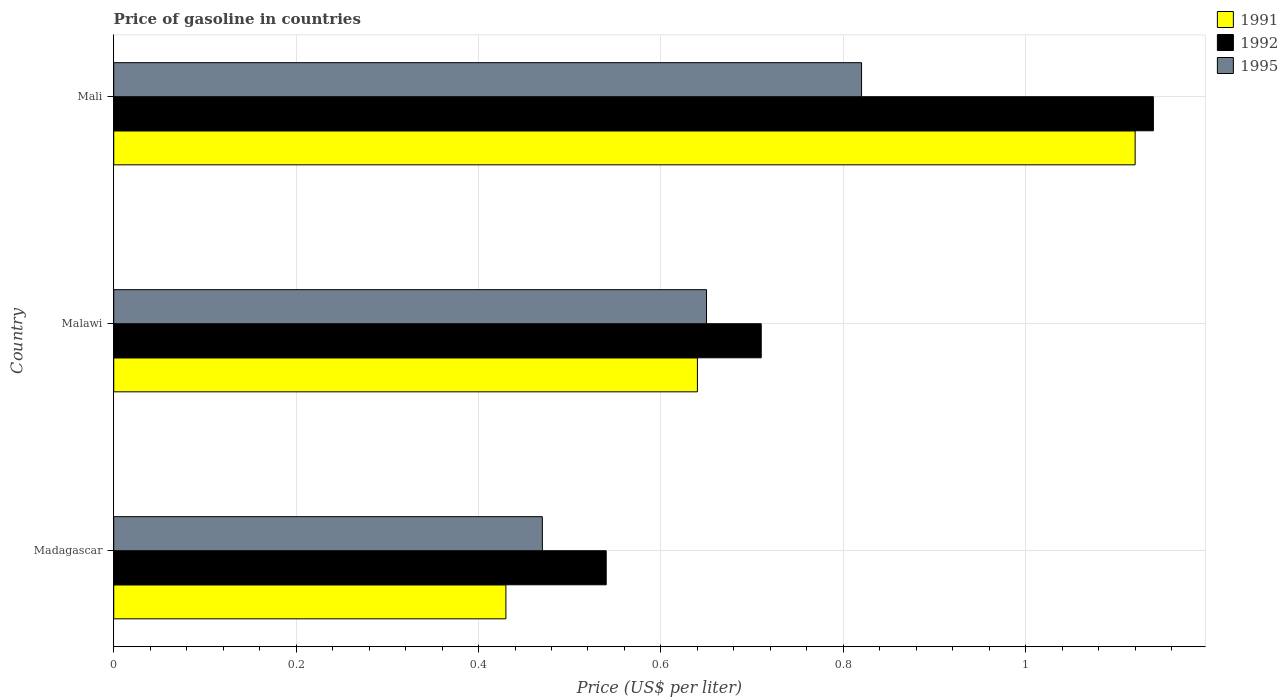How many groups of bars are there?
Make the answer very short. 3. Are the number of bars per tick equal to the number of legend labels?
Your response must be concise. Yes. Are the number of bars on each tick of the Y-axis equal?
Your answer should be compact. Yes. What is the label of the 1st group of bars from the top?
Ensure brevity in your answer.  Mali. In how many cases, is the number of bars for a given country not equal to the number of legend labels?
Make the answer very short. 0. What is the price of gasoline in 1995 in Mali?
Ensure brevity in your answer.  0.82. Across all countries, what is the maximum price of gasoline in 1992?
Your answer should be very brief. 1.14. Across all countries, what is the minimum price of gasoline in 1995?
Your answer should be very brief. 0.47. In which country was the price of gasoline in 1992 maximum?
Offer a very short reply. Mali. In which country was the price of gasoline in 1991 minimum?
Offer a terse response. Madagascar. What is the total price of gasoline in 1995 in the graph?
Provide a short and direct response. 1.94. What is the difference between the price of gasoline in 1992 in Madagascar and that in Mali?
Keep it short and to the point. -0.6. What is the difference between the price of gasoline in 1992 in Malawi and the price of gasoline in 1995 in Mali?
Offer a very short reply. -0.11. What is the average price of gasoline in 1992 per country?
Your answer should be very brief. 0.8. What is the difference between the price of gasoline in 1991 and price of gasoline in 1992 in Madagascar?
Offer a very short reply. -0.11. What is the ratio of the price of gasoline in 1991 in Madagascar to that in Mali?
Keep it short and to the point. 0.38. What is the difference between the highest and the second highest price of gasoline in 1991?
Your answer should be very brief. 0.48. What is the difference between the highest and the lowest price of gasoline in 1995?
Provide a short and direct response. 0.35. In how many countries, is the price of gasoline in 1995 greater than the average price of gasoline in 1995 taken over all countries?
Ensure brevity in your answer.  2. Is the sum of the price of gasoline in 1992 in Malawi and Mali greater than the maximum price of gasoline in 1995 across all countries?
Offer a very short reply. Yes. Is it the case that in every country, the sum of the price of gasoline in 1991 and price of gasoline in 1995 is greater than the price of gasoline in 1992?
Give a very brief answer. Yes. Are all the bars in the graph horizontal?
Your response must be concise. Yes. Are the values on the major ticks of X-axis written in scientific E-notation?
Offer a terse response. No. Does the graph contain any zero values?
Provide a short and direct response. No. How many legend labels are there?
Your response must be concise. 3. What is the title of the graph?
Provide a succinct answer. Price of gasoline in countries. What is the label or title of the X-axis?
Offer a terse response. Price (US$ per liter). What is the Price (US$ per liter) of 1991 in Madagascar?
Keep it short and to the point. 0.43. What is the Price (US$ per liter) in 1992 in Madagascar?
Offer a very short reply. 0.54. What is the Price (US$ per liter) in 1995 in Madagascar?
Your answer should be compact. 0.47. What is the Price (US$ per liter) in 1991 in Malawi?
Provide a succinct answer. 0.64. What is the Price (US$ per liter) of 1992 in Malawi?
Your answer should be compact. 0.71. What is the Price (US$ per liter) of 1995 in Malawi?
Provide a short and direct response. 0.65. What is the Price (US$ per liter) in 1991 in Mali?
Make the answer very short. 1.12. What is the Price (US$ per liter) of 1992 in Mali?
Make the answer very short. 1.14. What is the Price (US$ per liter) in 1995 in Mali?
Offer a terse response. 0.82. Across all countries, what is the maximum Price (US$ per liter) of 1991?
Offer a very short reply. 1.12. Across all countries, what is the maximum Price (US$ per liter) in 1992?
Offer a terse response. 1.14. Across all countries, what is the maximum Price (US$ per liter) in 1995?
Ensure brevity in your answer.  0.82. Across all countries, what is the minimum Price (US$ per liter) of 1991?
Your answer should be very brief. 0.43. Across all countries, what is the minimum Price (US$ per liter) of 1992?
Offer a terse response. 0.54. Across all countries, what is the minimum Price (US$ per liter) of 1995?
Ensure brevity in your answer.  0.47. What is the total Price (US$ per liter) of 1991 in the graph?
Provide a succinct answer. 2.19. What is the total Price (US$ per liter) of 1992 in the graph?
Keep it short and to the point. 2.39. What is the total Price (US$ per liter) in 1995 in the graph?
Offer a terse response. 1.94. What is the difference between the Price (US$ per liter) of 1991 in Madagascar and that in Malawi?
Keep it short and to the point. -0.21. What is the difference between the Price (US$ per liter) of 1992 in Madagascar and that in Malawi?
Ensure brevity in your answer.  -0.17. What is the difference between the Price (US$ per liter) in 1995 in Madagascar and that in Malawi?
Offer a terse response. -0.18. What is the difference between the Price (US$ per liter) in 1991 in Madagascar and that in Mali?
Your answer should be very brief. -0.69. What is the difference between the Price (US$ per liter) of 1992 in Madagascar and that in Mali?
Offer a terse response. -0.6. What is the difference between the Price (US$ per liter) of 1995 in Madagascar and that in Mali?
Keep it short and to the point. -0.35. What is the difference between the Price (US$ per liter) of 1991 in Malawi and that in Mali?
Make the answer very short. -0.48. What is the difference between the Price (US$ per liter) in 1992 in Malawi and that in Mali?
Make the answer very short. -0.43. What is the difference between the Price (US$ per liter) in 1995 in Malawi and that in Mali?
Give a very brief answer. -0.17. What is the difference between the Price (US$ per liter) in 1991 in Madagascar and the Price (US$ per liter) in 1992 in Malawi?
Offer a very short reply. -0.28. What is the difference between the Price (US$ per liter) of 1991 in Madagascar and the Price (US$ per liter) of 1995 in Malawi?
Give a very brief answer. -0.22. What is the difference between the Price (US$ per liter) in 1992 in Madagascar and the Price (US$ per liter) in 1995 in Malawi?
Offer a very short reply. -0.11. What is the difference between the Price (US$ per liter) of 1991 in Madagascar and the Price (US$ per liter) of 1992 in Mali?
Provide a succinct answer. -0.71. What is the difference between the Price (US$ per liter) in 1991 in Madagascar and the Price (US$ per liter) in 1995 in Mali?
Ensure brevity in your answer.  -0.39. What is the difference between the Price (US$ per liter) of 1992 in Madagascar and the Price (US$ per liter) of 1995 in Mali?
Give a very brief answer. -0.28. What is the difference between the Price (US$ per liter) in 1991 in Malawi and the Price (US$ per liter) in 1992 in Mali?
Provide a short and direct response. -0.5. What is the difference between the Price (US$ per liter) of 1991 in Malawi and the Price (US$ per liter) of 1995 in Mali?
Ensure brevity in your answer.  -0.18. What is the difference between the Price (US$ per liter) of 1992 in Malawi and the Price (US$ per liter) of 1995 in Mali?
Your answer should be very brief. -0.11. What is the average Price (US$ per liter) of 1991 per country?
Offer a very short reply. 0.73. What is the average Price (US$ per liter) of 1992 per country?
Your response must be concise. 0.8. What is the average Price (US$ per liter) in 1995 per country?
Give a very brief answer. 0.65. What is the difference between the Price (US$ per liter) in 1991 and Price (US$ per liter) in 1992 in Madagascar?
Your response must be concise. -0.11. What is the difference between the Price (US$ per liter) in 1991 and Price (US$ per liter) in 1995 in Madagascar?
Keep it short and to the point. -0.04. What is the difference between the Price (US$ per liter) in 1992 and Price (US$ per liter) in 1995 in Madagascar?
Your answer should be very brief. 0.07. What is the difference between the Price (US$ per liter) in 1991 and Price (US$ per liter) in 1992 in Malawi?
Keep it short and to the point. -0.07. What is the difference between the Price (US$ per liter) of 1991 and Price (US$ per liter) of 1995 in Malawi?
Provide a short and direct response. -0.01. What is the difference between the Price (US$ per liter) of 1992 and Price (US$ per liter) of 1995 in Malawi?
Your answer should be compact. 0.06. What is the difference between the Price (US$ per liter) of 1991 and Price (US$ per liter) of 1992 in Mali?
Your answer should be very brief. -0.02. What is the difference between the Price (US$ per liter) in 1991 and Price (US$ per liter) in 1995 in Mali?
Give a very brief answer. 0.3. What is the difference between the Price (US$ per liter) of 1992 and Price (US$ per liter) of 1995 in Mali?
Provide a short and direct response. 0.32. What is the ratio of the Price (US$ per liter) in 1991 in Madagascar to that in Malawi?
Your response must be concise. 0.67. What is the ratio of the Price (US$ per liter) of 1992 in Madagascar to that in Malawi?
Your answer should be very brief. 0.76. What is the ratio of the Price (US$ per liter) of 1995 in Madagascar to that in Malawi?
Offer a terse response. 0.72. What is the ratio of the Price (US$ per liter) of 1991 in Madagascar to that in Mali?
Keep it short and to the point. 0.38. What is the ratio of the Price (US$ per liter) of 1992 in Madagascar to that in Mali?
Make the answer very short. 0.47. What is the ratio of the Price (US$ per liter) in 1995 in Madagascar to that in Mali?
Provide a succinct answer. 0.57. What is the ratio of the Price (US$ per liter) in 1992 in Malawi to that in Mali?
Offer a terse response. 0.62. What is the ratio of the Price (US$ per liter) in 1995 in Malawi to that in Mali?
Make the answer very short. 0.79. What is the difference between the highest and the second highest Price (US$ per liter) in 1991?
Provide a succinct answer. 0.48. What is the difference between the highest and the second highest Price (US$ per liter) of 1992?
Give a very brief answer. 0.43. What is the difference between the highest and the second highest Price (US$ per liter) in 1995?
Your response must be concise. 0.17. What is the difference between the highest and the lowest Price (US$ per liter) of 1991?
Your answer should be compact. 0.69. What is the difference between the highest and the lowest Price (US$ per liter) in 1995?
Keep it short and to the point. 0.35. 